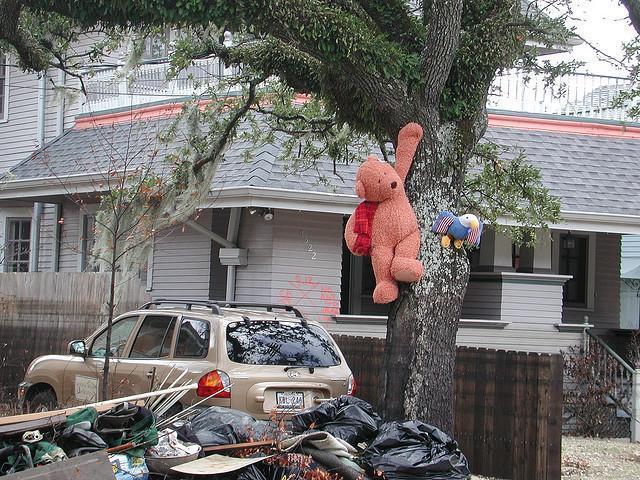How many animals are in the tree?
Give a very brief answer. 2. 